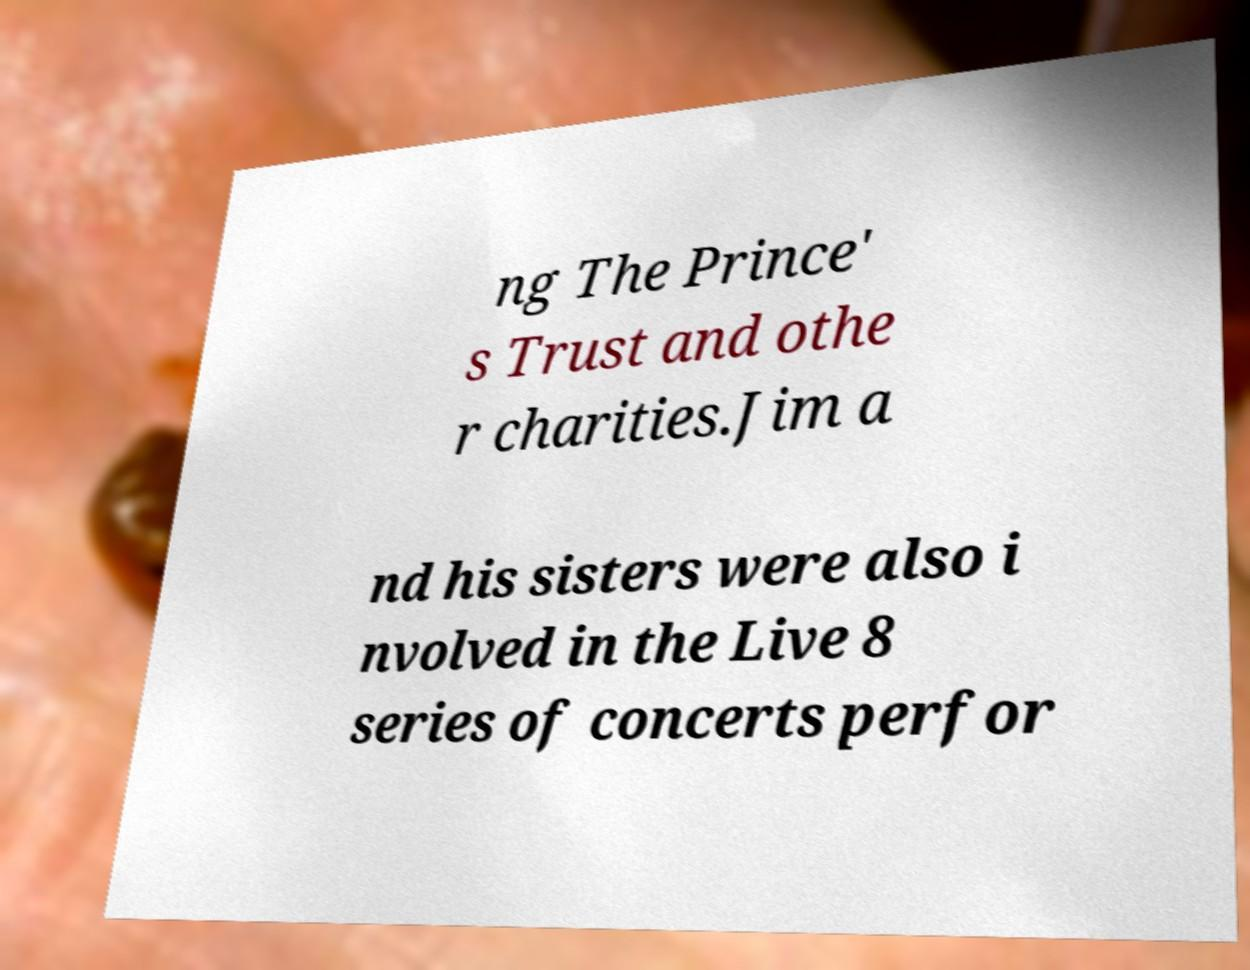I need the written content from this picture converted into text. Can you do that? ng The Prince' s Trust and othe r charities.Jim a nd his sisters were also i nvolved in the Live 8 series of concerts perfor 